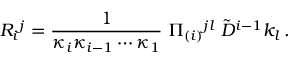Convert formula to latex. <formula><loc_0><loc_0><loc_500><loc_500>R _ { i ^ { j } = { \frac { 1 } { \kappa _ { i } \kappa _ { i - 1 } \cdots \kappa _ { 1 } } } \, \Pi _ { ( i ) ^ { j l } \, \tilde { D } ^ { i - 1 } k _ { l } \, .</formula> 